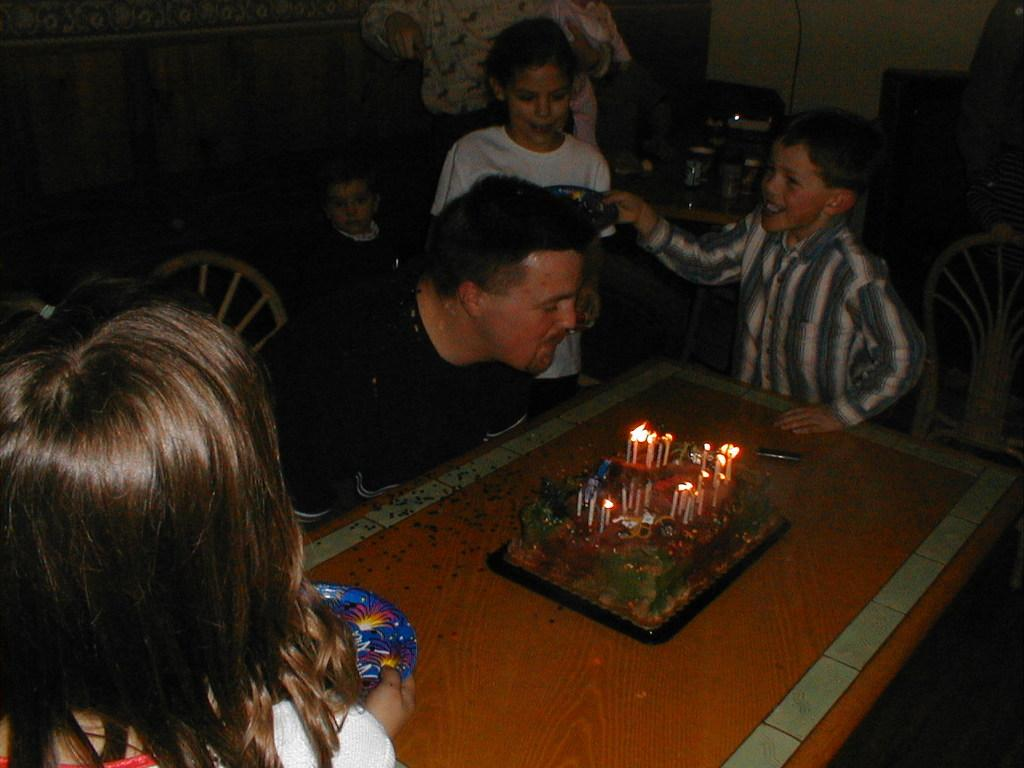What is the man in the image doing? The man is blowing candles on a cake. Where is the cake located in the image? The cake is on a table. Who else is present in the image besides the man? There are kids in front of the table and a woman behind the table. What type of room might this scene be taking place in? The setting appears to be a dining room. What type of sea creature can be seen swimming in the background of the image? There is no sea creature present in the image; it takes place in a dining room. How does the railway system impact the celebration in the image? There is no railway system mentioned or depicted in the image. 